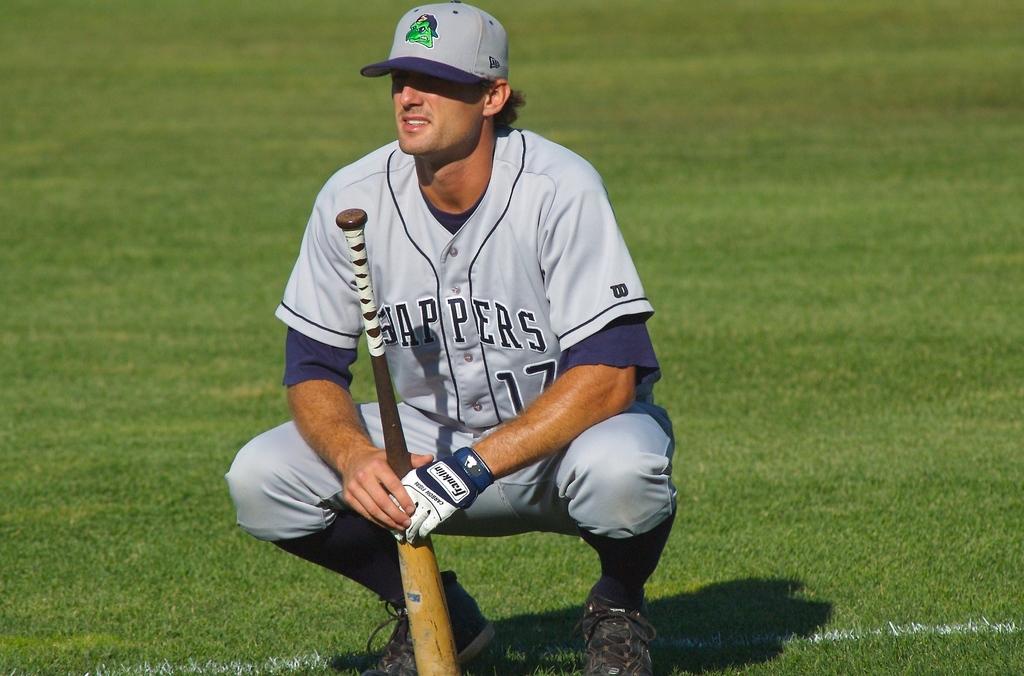What is the brand of the player's batting glove?
Offer a terse response. Franklin. 